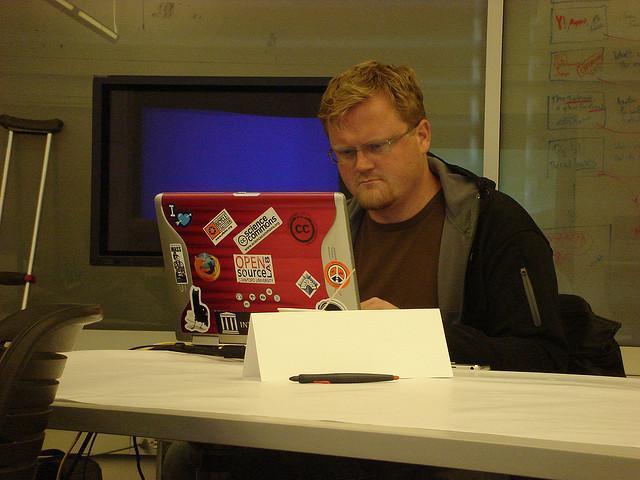How many laptops?
Give a very brief answer. 1. How many people are wearing glasses?
Give a very brief answer. 1. How many men are in the photo?
Give a very brief answer. 1. How many men in the photo?
Give a very brief answer. 1. How many laptops are on the white table?
Give a very brief answer. 1. How many wear glasses?
Give a very brief answer. 1. How many people at the table?
Give a very brief answer. 1. How many people are there?
Give a very brief answer. 1. How many laptops can be seen?
Give a very brief answer. 1. How many chairs are there?
Give a very brief answer. 2. How many bottles on the cutting board are uncorked?
Give a very brief answer. 0. 